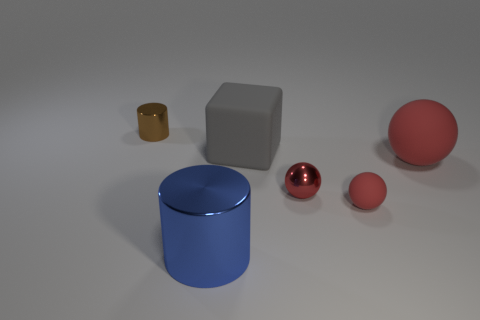What number of objects are either blue shiny cylinders or purple rubber cylinders?
Provide a succinct answer. 1. Does the brown cylinder have the same material as the small red object to the left of the small rubber thing?
Your answer should be very brief. Yes. Are there any other things that are the same color as the matte cube?
Provide a succinct answer. No. What number of things are either big objects behind the big blue thing or large blocks that are on the left side of the tiny red metallic thing?
Offer a very short reply. 2. What is the shape of the matte object that is behind the tiny shiny sphere and right of the large gray object?
Your response must be concise. Sphere. What number of small objects are in front of the red ball on the right side of the small red rubber object?
Give a very brief answer. 2. Are there any other things that are made of the same material as the big red thing?
Offer a very short reply. Yes. How many objects are cylinders to the left of the large blue metallic cylinder or blocks?
Provide a short and direct response. 2. How big is the metallic object to the right of the large cylinder?
Make the answer very short. Small. What material is the big gray thing?
Your answer should be compact. Rubber. 